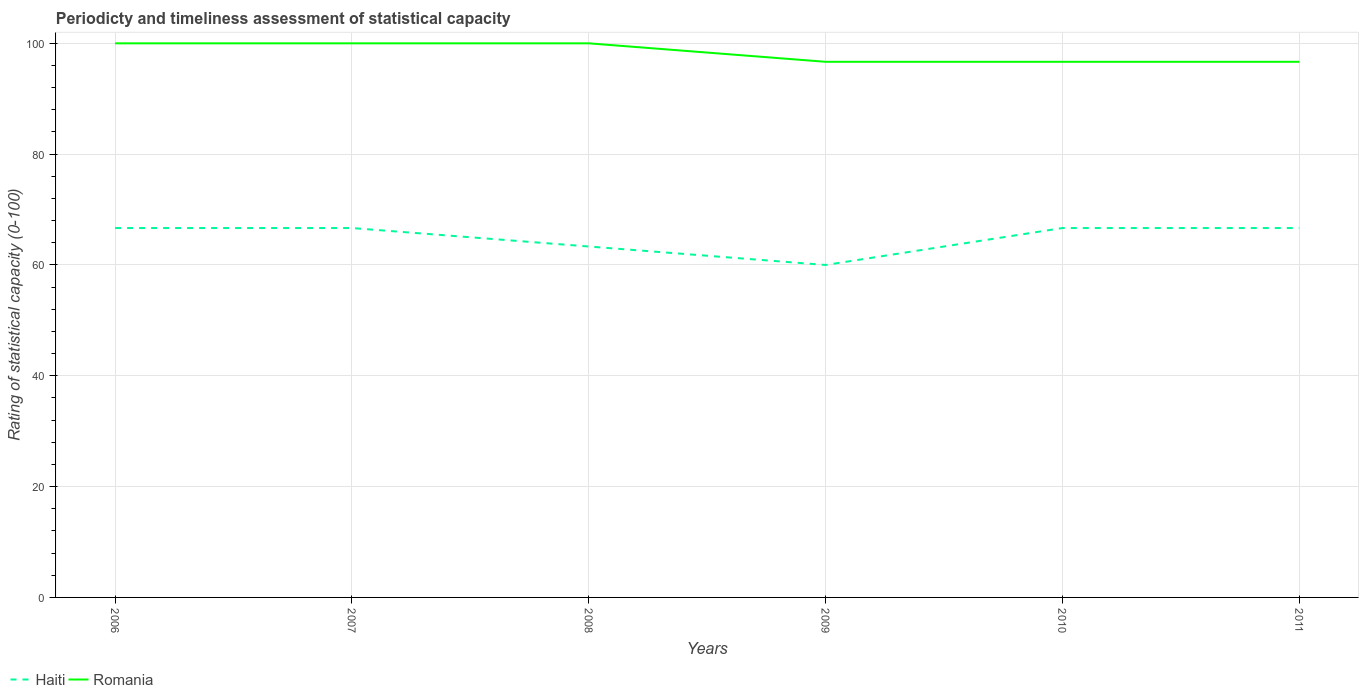Does the line corresponding to Romania intersect with the line corresponding to Haiti?
Give a very brief answer. No. In which year was the rating of statistical capacity in Romania maximum?
Your answer should be very brief. 2009. What is the total rating of statistical capacity in Haiti in the graph?
Give a very brief answer. 0. What is the difference between the highest and the second highest rating of statistical capacity in Romania?
Provide a short and direct response. 3.33. What is the difference between the highest and the lowest rating of statistical capacity in Haiti?
Provide a short and direct response. 4. Is the rating of statistical capacity in Romania strictly greater than the rating of statistical capacity in Haiti over the years?
Offer a very short reply. No. What is the difference between two consecutive major ticks on the Y-axis?
Ensure brevity in your answer.  20. Does the graph contain any zero values?
Give a very brief answer. No. How many legend labels are there?
Your response must be concise. 2. How are the legend labels stacked?
Provide a short and direct response. Horizontal. What is the title of the graph?
Offer a terse response. Periodicty and timeliness assessment of statistical capacity. Does "Zimbabwe" appear as one of the legend labels in the graph?
Your answer should be very brief. No. What is the label or title of the Y-axis?
Your answer should be very brief. Rating of statistical capacity (0-100). What is the Rating of statistical capacity (0-100) in Haiti in 2006?
Make the answer very short. 66.67. What is the Rating of statistical capacity (0-100) of Haiti in 2007?
Provide a short and direct response. 66.67. What is the Rating of statistical capacity (0-100) in Romania in 2007?
Keep it short and to the point. 100. What is the Rating of statistical capacity (0-100) in Haiti in 2008?
Offer a terse response. 63.33. What is the Rating of statistical capacity (0-100) in Haiti in 2009?
Ensure brevity in your answer.  60. What is the Rating of statistical capacity (0-100) of Romania in 2009?
Ensure brevity in your answer.  96.67. What is the Rating of statistical capacity (0-100) in Haiti in 2010?
Make the answer very short. 66.67. What is the Rating of statistical capacity (0-100) in Romania in 2010?
Ensure brevity in your answer.  96.67. What is the Rating of statistical capacity (0-100) in Haiti in 2011?
Make the answer very short. 66.67. What is the Rating of statistical capacity (0-100) of Romania in 2011?
Your answer should be very brief. 96.67. Across all years, what is the maximum Rating of statistical capacity (0-100) of Haiti?
Your answer should be compact. 66.67. Across all years, what is the maximum Rating of statistical capacity (0-100) in Romania?
Give a very brief answer. 100. Across all years, what is the minimum Rating of statistical capacity (0-100) in Romania?
Offer a very short reply. 96.67. What is the total Rating of statistical capacity (0-100) in Haiti in the graph?
Ensure brevity in your answer.  390. What is the total Rating of statistical capacity (0-100) of Romania in the graph?
Your answer should be very brief. 590. What is the difference between the Rating of statistical capacity (0-100) in Romania in 2006 and that in 2007?
Offer a very short reply. 0. What is the difference between the Rating of statistical capacity (0-100) in Haiti in 2006 and that in 2008?
Your answer should be very brief. 3.33. What is the difference between the Rating of statistical capacity (0-100) in Romania in 2006 and that in 2009?
Your answer should be very brief. 3.33. What is the difference between the Rating of statistical capacity (0-100) of Romania in 2006 and that in 2011?
Make the answer very short. 3.33. What is the difference between the Rating of statistical capacity (0-100) in Haiti in 2007 and that in 2009?
Make the answer very short. 6.67. What is the difference between the Rating of statistical capacity (0-100) in Romania in 2007 and that in 2009?
Offer a terse response. 3.33. What is the difference between the Rating of statistical capacity (0-100) of Haiti in 2007 and that in 2010?
Make the answer very short. 0. What is the difference between the Rating of statistical capacity (0-100) of Romania in 2007 and that in 2010?
Your answer should be compact. 3.33. What is the difference between the Rating of statistical capacity (0-100) in Haiti in 2007 and that in 2011?
Ensure brevity in your answer.  0. What is the difference between the Rating of statistical capacity (0-100) of Romania in 2007 and that in 2011?
Make the answer very short. 3.33. What is the difference between the Rating of statistical capacity (0-100) in Haiti in 2008 and that in 2010?
Ensure brevity in your answer.  -3.33. What is the difference between the Rating of statistical capacity (0-100) in Romania in 2008 and that in 2011?
Provide a succinct answer. 3.33. What is the difference between the Rating of statistical capacity (0-100) in Haiti in 2009 and that in 2010?
Provide a short and direct response. -6.67. What is the difference between the Rating of statistical capacity (0-100) in Romania in 2009 and that in 2010?
Offer a very short reply. 0. What is the difference between the Rating of statistical capacity (0-100) in Haiti in 2009 and that in 2011?
Keep it short and to the point. -6.67. What is the difference between the Rating of statistical capacity (0-100) in Romania in 2010 and that in 2011?
Provide a short and direct response. 0. What is the difference between the Rating of statistical capacity (0-100) of Haiti in 2006 and the Rating of statistical capacity (0-100) of Romania in 2007?
Offer a terse response. -33.33. What is the difference between the Rating of statistical capacity (0-100) of Haiti in 2006 and the Rating of statistical capacity (0-100) of Romania in 2008?
Offer a very short reply. -33.33. What is the difference between the Rating of statistical capacity (0-100) of Haiti in 2006 and the Rating of statistical capacity (0-100) of Romania in 2011?
Provide a short and direct response. -30. What is the difference between the Rating of statistical capacity (0-100) in Haiti in 2007 and the Rating of statistical capacity (0-100) in Romania in 2008?
Your response must be concise. -33.33. What is the difference between the Rating of statistical capacity (0-100) in Haiti in 2008 and the Rating of statistical capacity (0-100) in Romania in 2009?
Keep it short and to the point. -33.33. What is the difference between the Rating of statistical capacity (0-100) in Haiti in 2008 and the Rating of statistical capacity (0-100) in Romania in 2010?
Provide a succinct answer. -33.33. What is the difference between the Rating of statistical capacity (0-100) of Haiti in 2008 and the Rating of statistical capacity (0-100) of Romania in 2011?
Offer a terse response. -33.33. What is the difference between the Rating of statistical capacity (0-100) of Haiti in 2009 and the Rating of statistical capacity (0-100) of Romania in 2010?
Your answer should be compact. -36.67. What is the difference between the Rating of statistical capacity (0-100) of Haiti in 2009 and the Rating of statistical capacity (0-100) of Romania in 2011?
Provide a short and direct response. -36.67. What is the difference between the Rating of statistical capacity (0-100) in Haiti in 2010 and the Rating of statistical capacity (0-100) in Romania in 2011?
Your answer should be compact. -30. What is the average Rating of statistical capacity (0-100) in Haiti per year?
Your answer should be compact. 65. What is the average Rating of statistical capacity (0-100) in Romania per year?
Provide a succinct answer. 98.33. In the year 2006, what is the difference between the Rating of statistical capacity (0-100) of Haiti and Rating of statistical capacity (0-100) of Romania?
Ensure brevity in your answer.  -33.33. In the year 2007, what is the difference between the Rating of statistical capacity (0-100) of Haiti and Rating of statistical capacity (0-100) of Romania?
Keep it short and to the point. -33.33. In the year 2008, what is the difference between the Rating of statistical capacity (0-100) of Haiti and Rating of statistical capacity (0-100) of Romania?
Ensure brevity in your answer.  -36.67. In the year 2009, what is the difference between the Rating of statistical capacity (0-100) in Haiti and Rating of statistical capacity (0-100) in Romania?
Offer a very short reply. -36.67. In the year 2010, what is the difference between the Rating of statistical capacity (0-100) in Haiti and Rating of statistical capacity (0-100) in Romania?
Your response must be concise. -30. In the year 2011, what is the difference between the Rating of statistical capacity (0-100) in Haiti and Rating of statistical capacity (0-100) in Romania?
Your response must be concise. -30. What is the ratio of the Rating of statistical capacity (0-100) in Haiti in 2006 to that in 2008?
Provide a short and direct response. 1.05. What is the ratio of the Rating of statistical capacity (0-100) of Romania in 2006 to that in 2008?
Your response must be concise. 1. What is the ratio of the Rating of statistical capacity (0-100) in Haiti in 2006 to that in 2009?
Offer a terse response. 1.11. What is the ratio of the Rating of statistical capacity (0-100) in Romania in 2006 to that in 2009?
Keep it short and to the point. 1.03. What is the ratio of the Rating of statistical capacity (0-100) in Haiti in 2006 to that in 2010?
Your response must be concise. 1. What is the ratio of the Rating of statistical capacity (0-100) in Romania in 2006 to that in 2010?
Make the answer very short. 1.03. What is the ratio of the Rating of statistical capacity (0-100) in Romania in 2006 to that in 2011?
Provide a short and direct response. 1.03. What is the ratio of the Rating of statistical capacity (0-100) in Haiti in 2007 to that in 2008?
Your answer should be very brief. 1.05. What is the ratio of the Rating of statistical capacity (0-100) of Romania in 2007 to that in 2009?
Offer a very short reply. 1.03. What is the ratio of the Rating of statistical capacity (0-100) in Haiti in 2007 to that in 2010?
Provide a succinct answer. 1. What is the ratio of the Rating of statistical capacity (0-100) in Romania in 2007 to that in 2010?
Offer a terse response. 1.03. What is the ratio of the Rating of statistical capacity (0-100) of Romania in 2007 to that in 2011?
Offer a very short reply. 1.03. What is the ratio of the Rating of statistical capacity (0-100) of Haiti in 2008 to that in 2009?
Give a very brief answer. 1.06. What is the ratio of the Rating of statistical capacity (0-100) in Romania in 2008 to that in 2009?
Your answer should be very brief. 1.03. What is the ratio of the Rating of statistical capacity (0-100) in Haiti in 2008 to that in 2010?
Your answer should be very brief. 0.95. What is the ratio of the Rating of statistical capacity (0-100) in Romania in 2008 to that in 2010?
Keep it short and to the point. 1.03. What is the ratio of the Rating of statistical capacity (0-100) of Romania in 2008 to that in 2011?
Ensure brevity in your answer.  1.03. What is the ratio of the Rating of statistical capacity (0-100) of Haiti in 2009 to that in 2010?
Give a very brief answer. 0.9. What is the ratio of the Rating of statistical capacity (0-100) in Romania in 2009 to that in 2010?
Your response must be concise. 1. What is the ratio of the Rating of statistical capacity (0-100) in Haiti in 2010 to that in 2011?
Your answer should be very brief. 1. What is the difference between the highest and the second highest Rating of statistical capacity (0-100) of Haiti?
Offer a very short reply. 0. What is the difference between the highest and the second highest Rating of statistical capacity (0-100) of Romania?
Provide a short and direct response. 0. What is the difference between the highest and the lowest Rating of statistical capacity (0-100) of Romania?
Give a very brief answer. 3.33. 